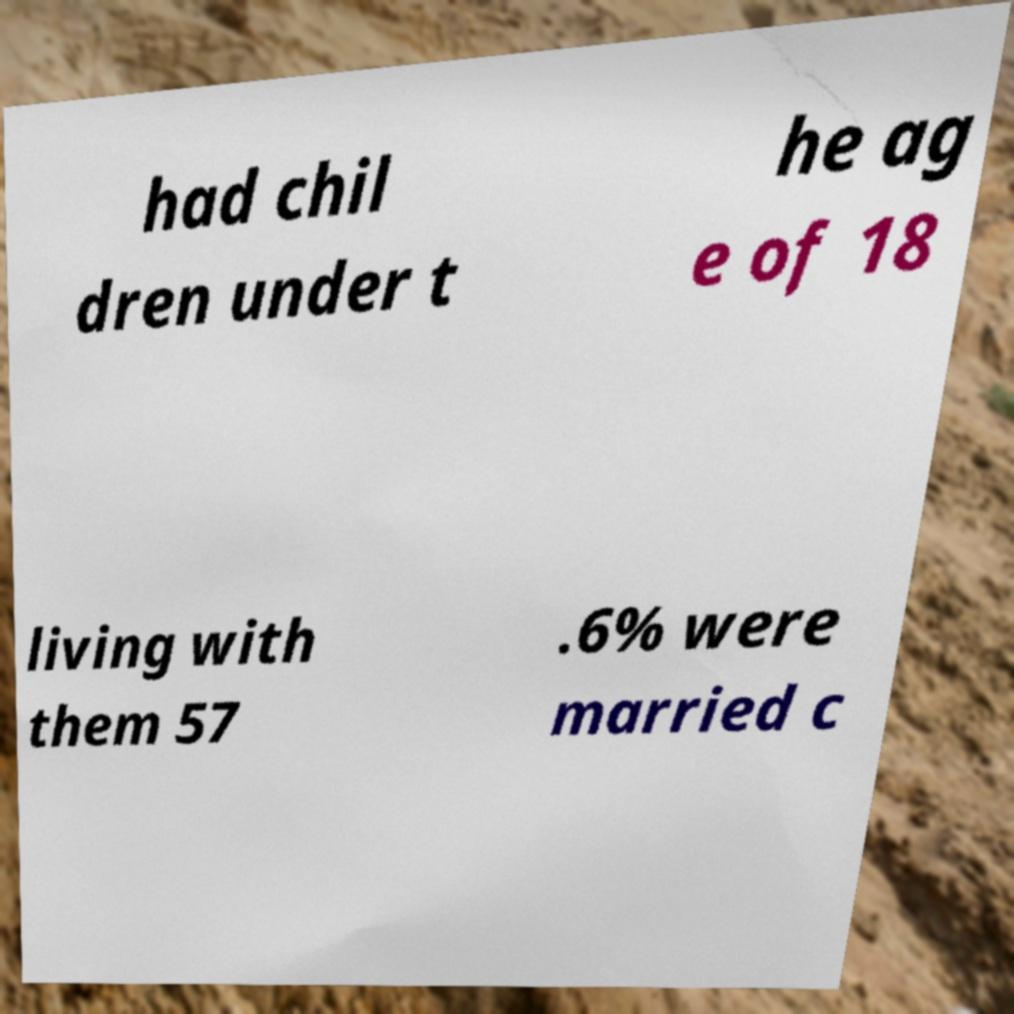For documentation purposes, I need the text within this image transcribed. Could you provide that? had chil dren under t he ag e of 18 living with them 57 .6% were married c 